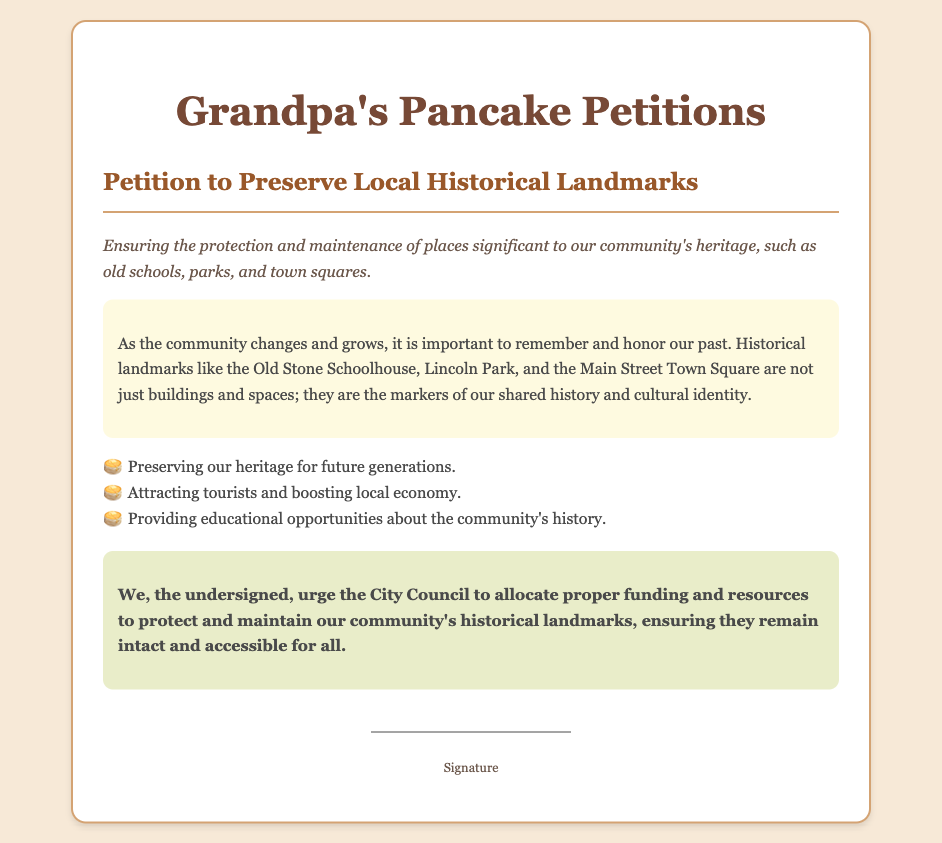What is the title of the petition? The title is the main heading of the document, which states the purpose of the petition.
Answer: Petition to Preserve Local Historical Landmarks What is the purpose of the petition? The purpose is specified right below the title and outlines the goal of the petition.
Answer: Ensuring the protection and maintenance of places significant to our community's heritage What are some examples of historical landmarks mentioned? The text provides specific examples that highlight the landmarks the petition aims to preserve.
Answer: Old Stone Schoolhouse, Lincoln Park, Main Street Town Square What is one benefit of preserving historical landmarks? The document lists multiple benefits of preserving the landmarks, highlighting their importance.
Answer: Preserving our heritage for future generations Who is urged to take action in this petition? The document specifies the group that the petition is directed to for action.
Answer: City Council What kind of support is being requested in the petition? The petition clearly outlines what is being requested from the authorities to achieve its aims.
Answer: Proper funding and resources What significance do the landmarks hold for the community? The background section explains why the landmarks are important to the residents.
Answer: Markers of our shared history and cultural identity What style is used in the document for the names of benefits? The document uses a specific styling technique to list the benefits, enhancing readability.
Answer: List style with icons What is the tone of the petition? The overall tone can be inferred from the language and intent expressed in the document.
Answer: Advocative 